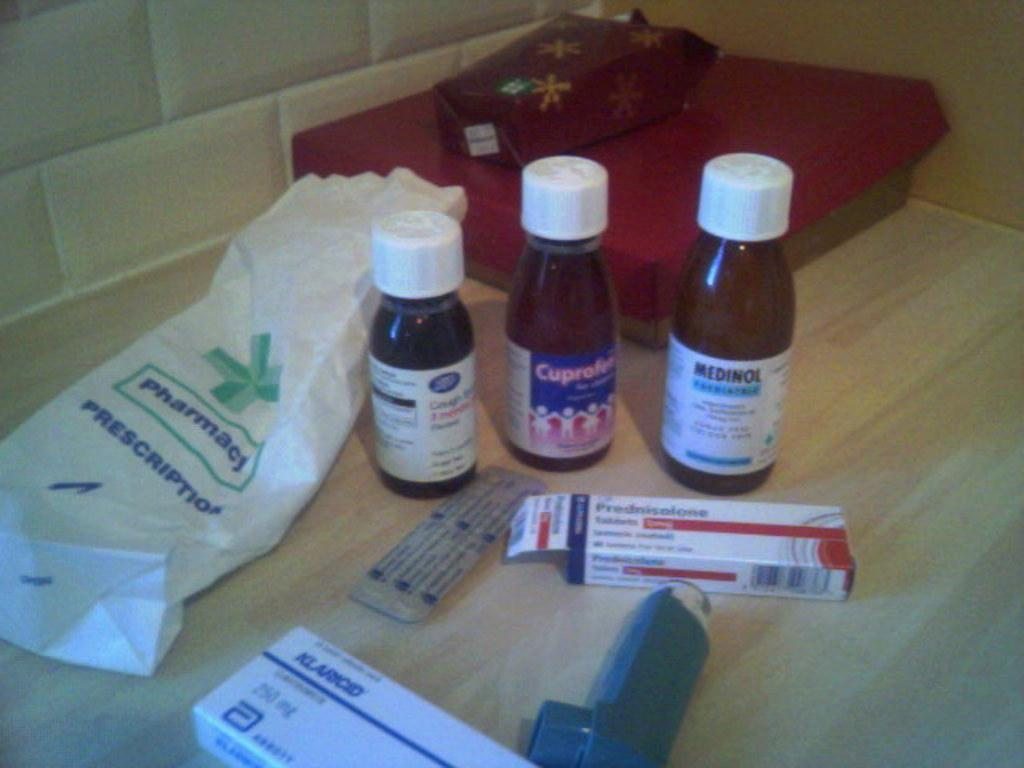<image>
Relay a brief, clear account of the picture shown. A bunch of different medicines from a pharmacy's perscription bag 